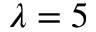<formula> <loc_0><loc_0><loc_500><loc_500>\lambda = 5</formula> 